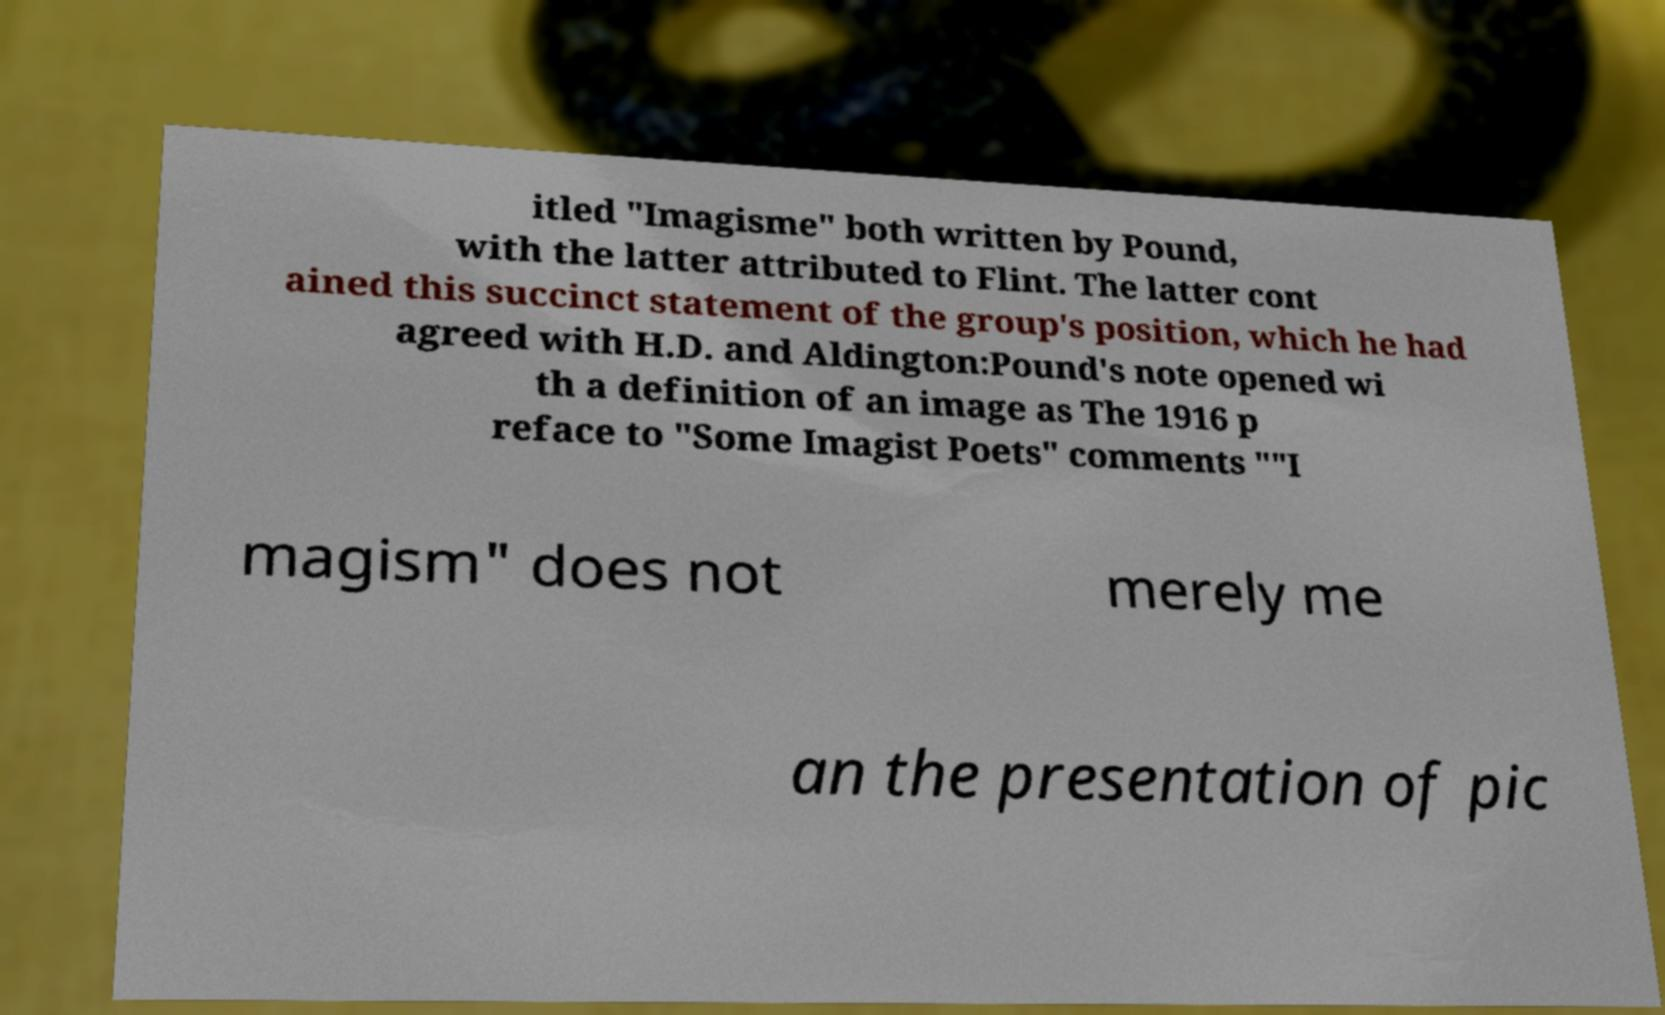What messages or text are displayed in this image? I need them in a readable, typed format. itled "Imagisme" both written by Pound, with the latter attributed to Flint. The latter cont ained this succinct statement of the group's position, which he had agreed with H.D. and Aldington:Pound's note opened wi th a definition of an image as The 1916 p reface to "Some Imagist Poets" comments ""I magism" does not merely me an the presentation of pic 